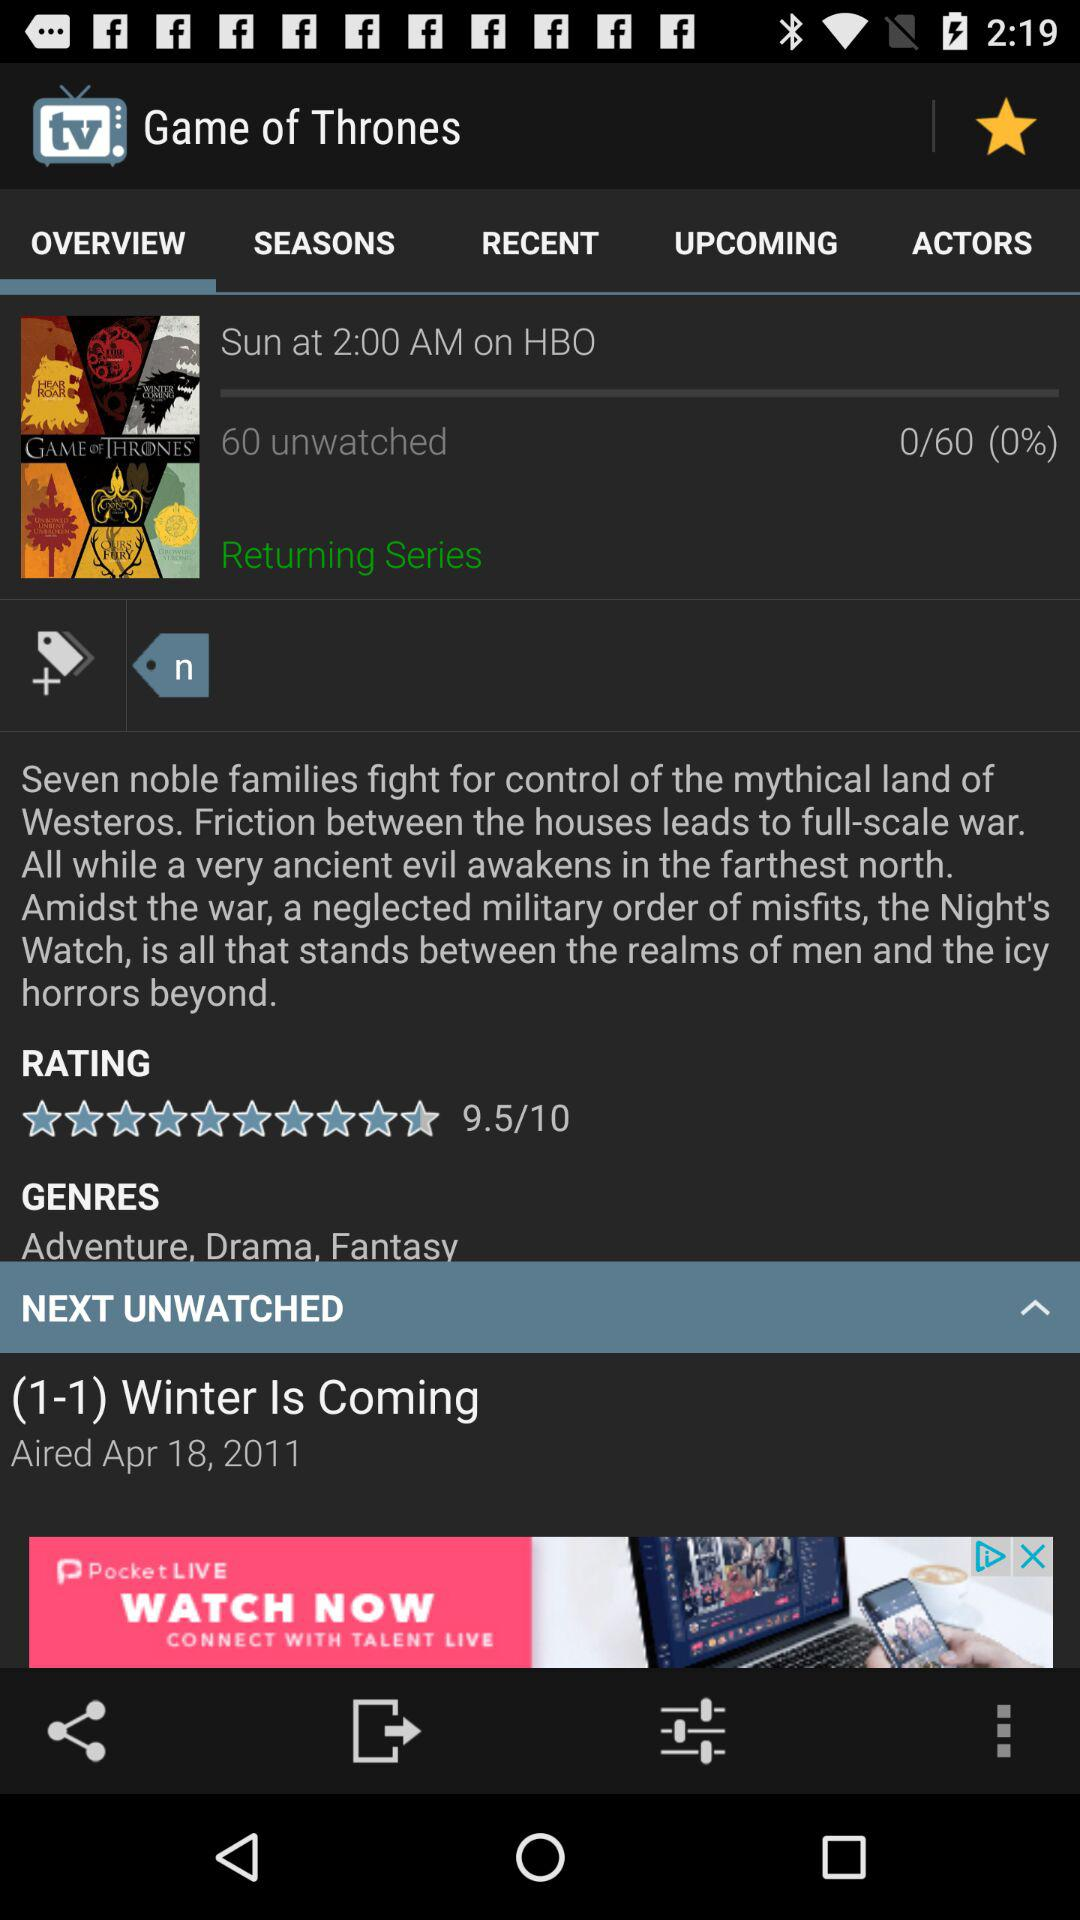When and on which channel did the television program "Game of Thrones" air? The television program "Game of Thrones" aired on Sunday at 2:00 AM on HBO. 